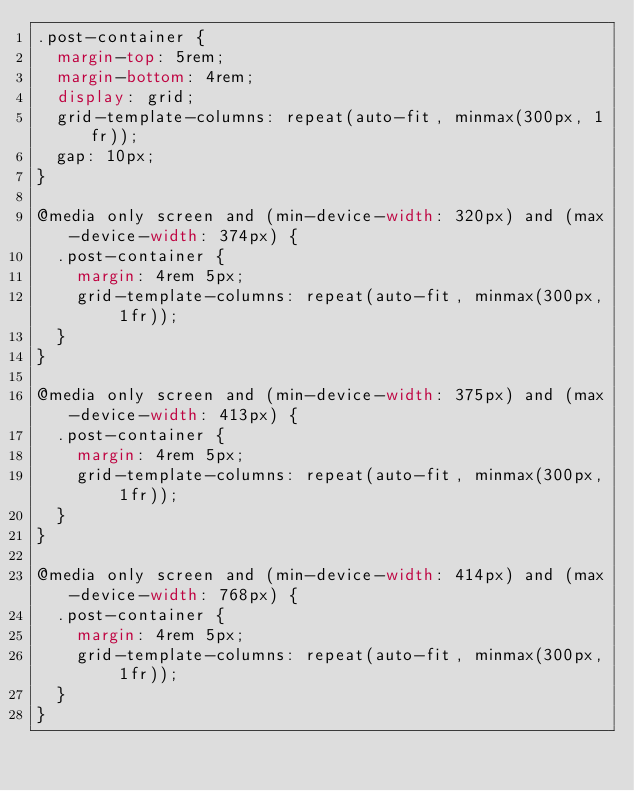Convert code to text. <code><loc_0><loc_0><loc_500><loc_500><_CSS_>.post-container {
  margin-top: 5rem;
  margin-bottom: 4rem;
  display: grid;
  grid-template-columns: repeat(auto-fit, minmax(300px, 1fr));
  gap: 10px;
}

@media only screen and (min-device-width: 320px) and (max-device-width: 374px) {
  .post-container {
    margin: 4rem 5px;
    grid-template-columns: repeat(auto-fit, minmax(300px, 1fr));
  }
}

@media only screen and (min-device-width: 375px) and (max-device-width: 413px) {
  .post-container {
    margin: 4rem 5px;
    grid-template-columns: repeat(auto-fit, minmax(300px, 1fr));
  }
}

@media only screen and (min-device-width: 414px) and (max-device-width: 768px) {
  .post-container {
    margin: 4rem 5px;
    grid-template-columns: repeat(auto-fit, minmax(300px, 1fr));
  }
}
</code> 